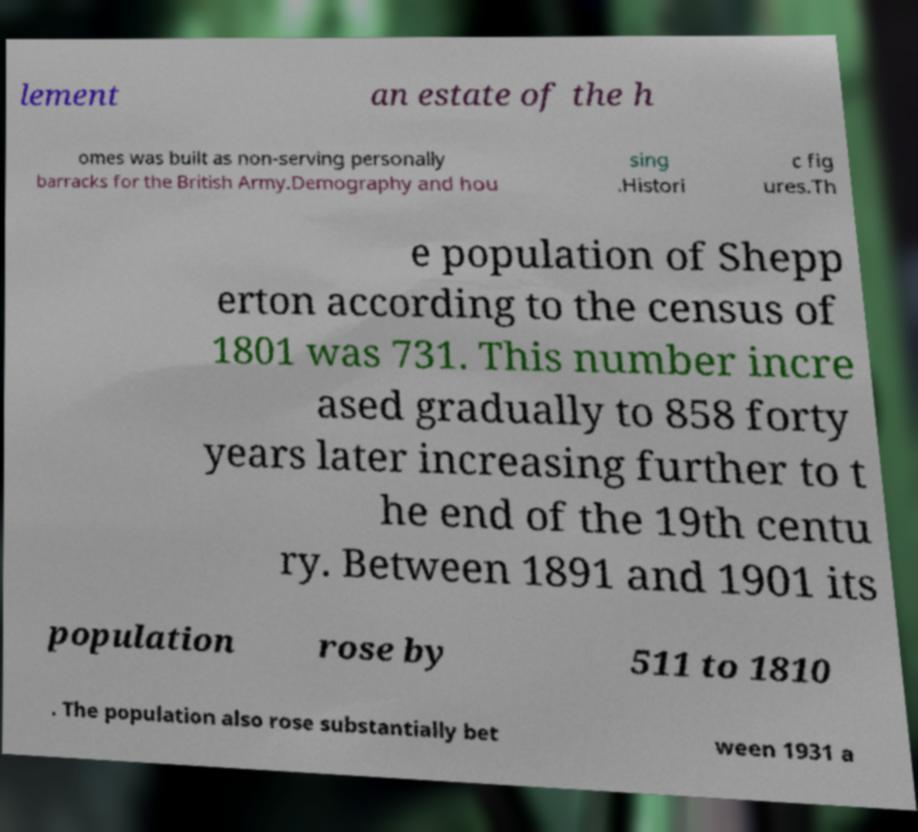Could you assist in decoding the text presented in this image and type it out clearly? lement an estate of the h omes was built as non-serving personally barracks for the British Army.Demography and hou sing .Histori c fig ures.Th e population of Shepp erton according to the census of 1801 was 731. This number incre ased gradually to 858 forty years later increasing further to t he end of the 19th centu ry. Between 1891 and 1901 its population rose by 511 to 1810 . The population also rose substantially bet ween 1931 a 